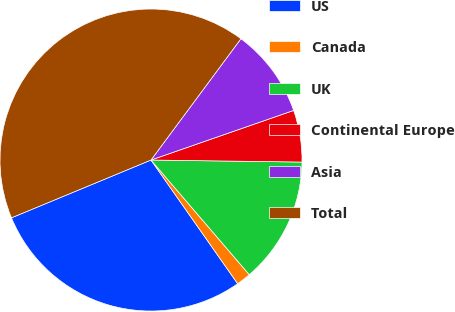Convert chart to OTSL. <chart><loc_0><loc_0><loc_500><loc_500><pie_chart><fcel>US<fcel>Canada<fcel>UK<fcel>Continental Europe<fcel>Asia<fcel>Total<nl><fcel>28.48%<fcel>1.55%<fcel>13.51%<fcel>5.54%<fcel>9.52%<fcel>41.41%<nl></chart> 